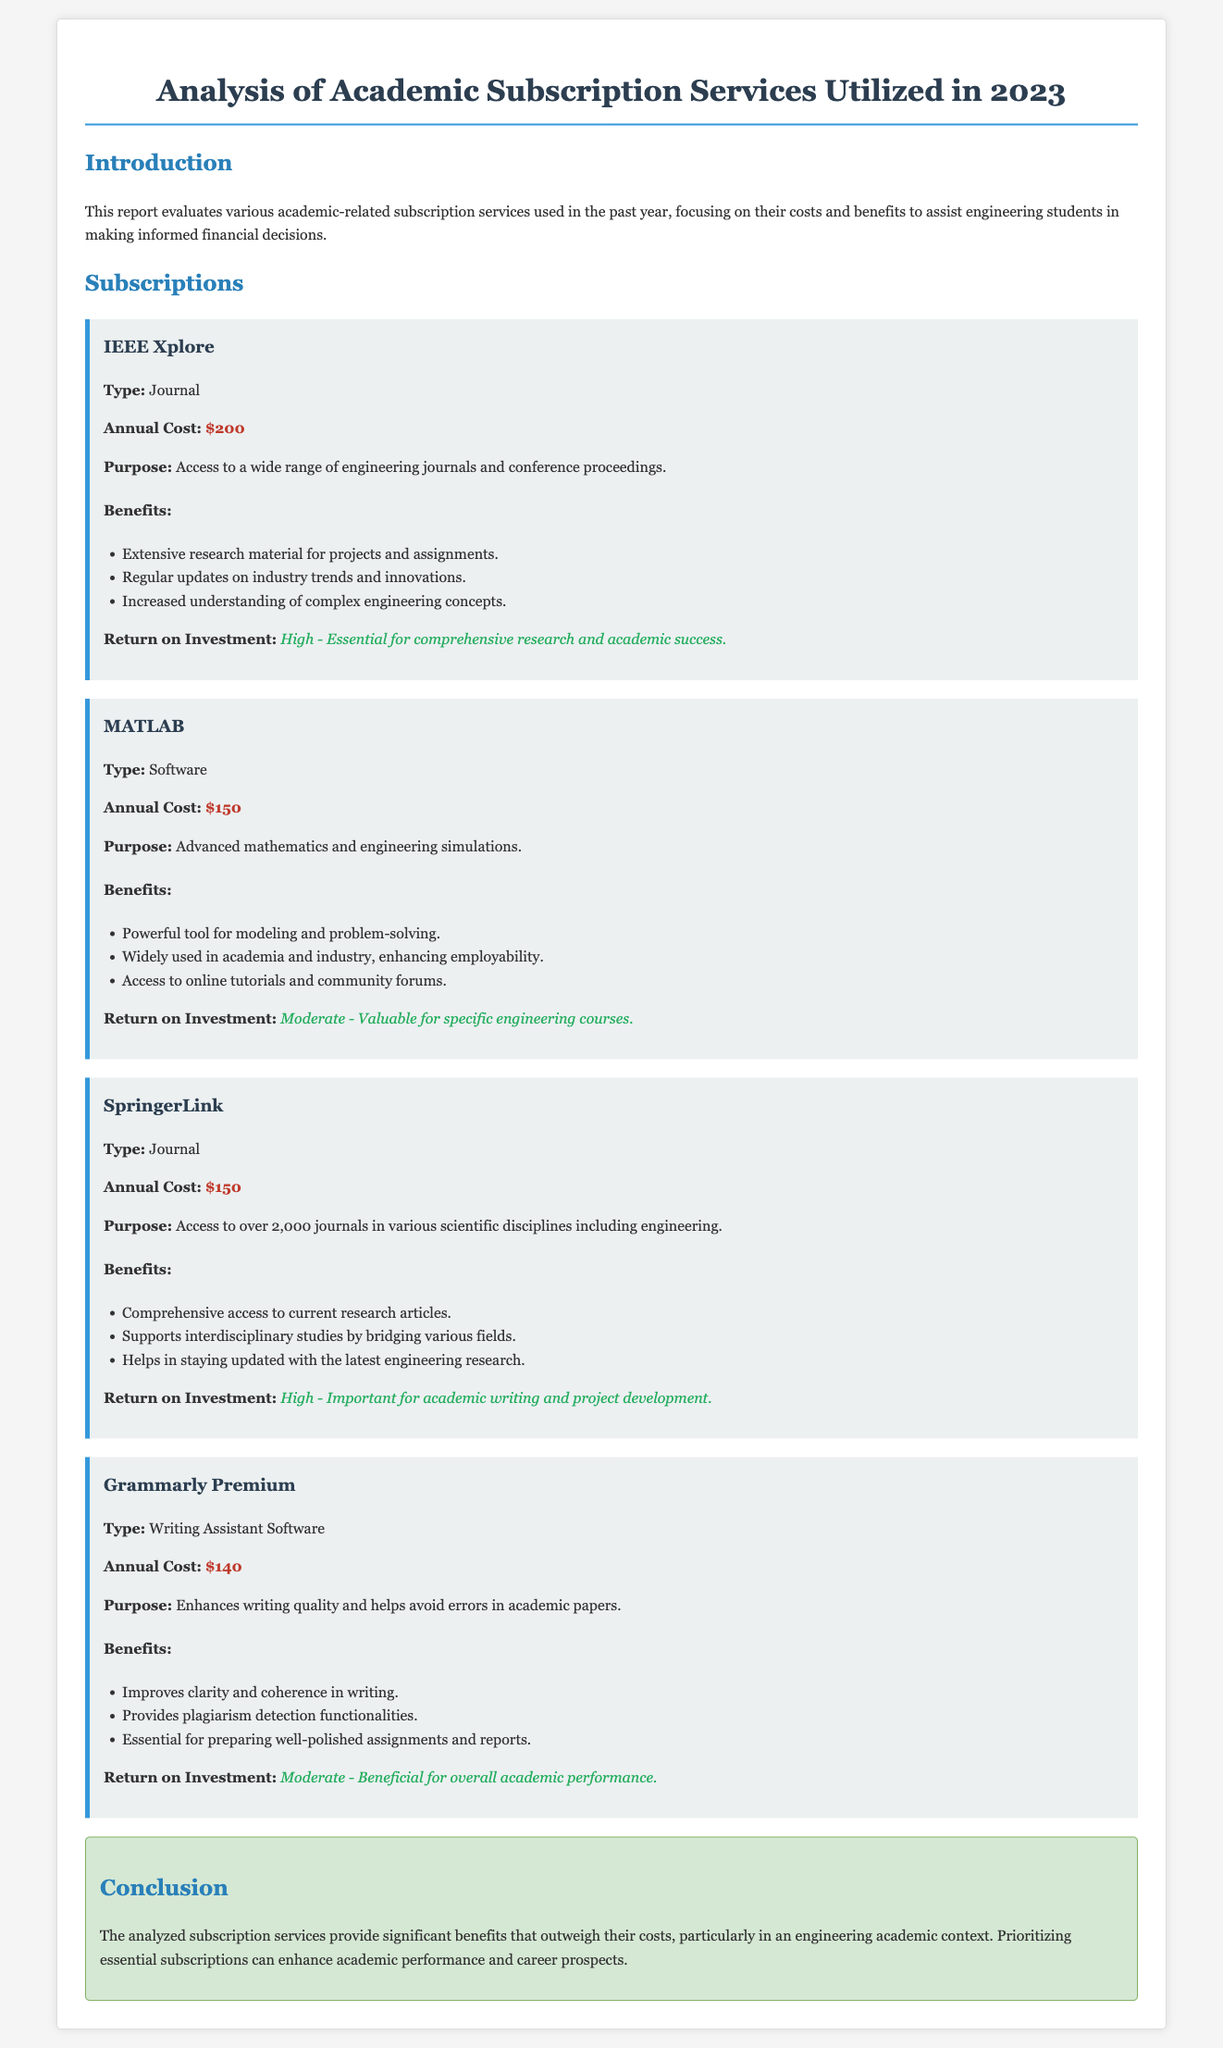What is the annual cost of IEEE Xplore? The annual cost of IEEE Xplore is explicitly mentioned in the document as $200.
Answer: $200 What is the purpose of MATLAB? The purpose of MATLAB is outlined in the document as advanced mathematics and engineering simulations.
Answer: Advanced mathematics and engineering simulations How many journals does SpringerLink provide access to? The document states that SpringerLink provides access to over 2,000 journals.
Answer: Over 2,000 journals What is the return on investment for Grammarly Premium? The return on investment for Grammarly Premium is classified as moderate in the document.
Answer: Moderate Which subscription is essential for comprehensive research? The document specifies that IEEE Xplore is essential for comprehensive research.
Answer: IEEE Xplore Which subscription provides plagiarism detection functionalities? Grammarly Premium is the subscription that offers plagiarism detection functionalities.
Answer: Grammarly Premium What type of software is Grammarly? The document categorizes Grammarly as a writing assistant software.
Answer: Writing Assistant Software What is the overall conclusion regarding the analyzed subscription services? The document concludes that the benefits of the analyzed subscription services outweigh their costs.
Answer: Benefits outweigh costs What type of subscription is MATLAB categorized as? MATLAB is categorized as software in the document.
Answer: Software 